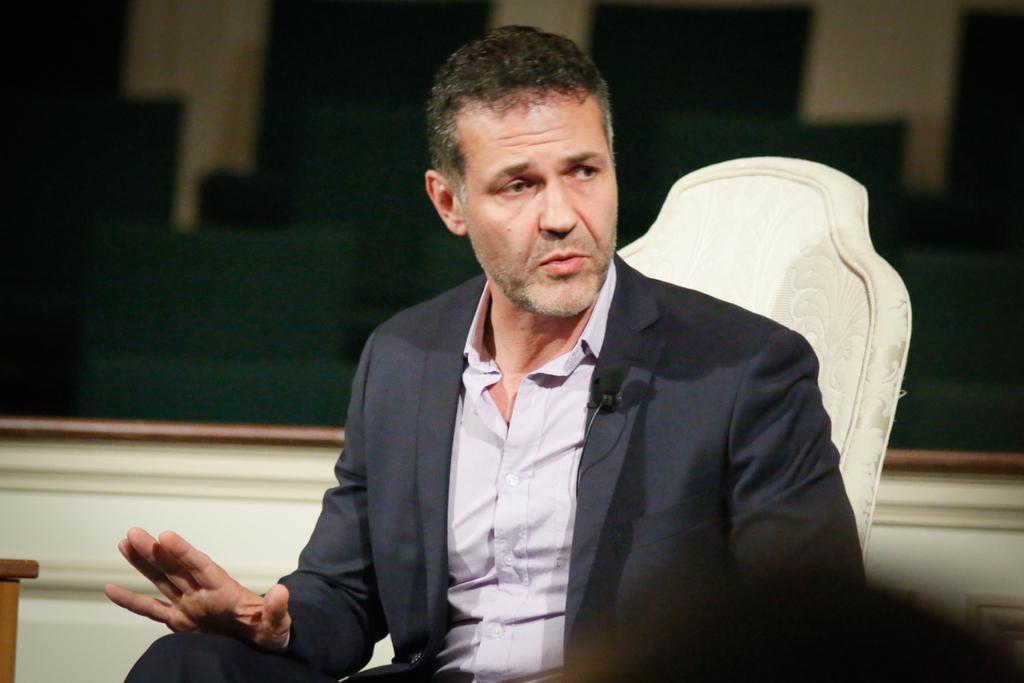How would you summarize this image in a sentence or two? As we can see in the image there are is wall, a man wearing black color jacket and sitting on chair. 